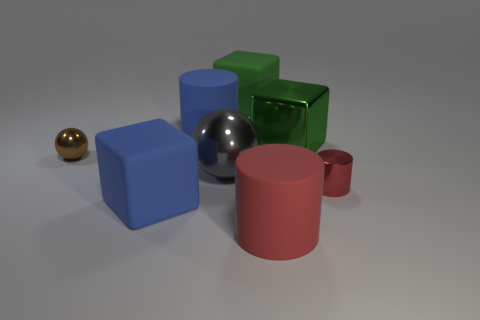How many things are either small metallic objects or small purple rubber cubes?
Your answer should be compact. 2. There is a metal object that is both on the right side of the brown shiny object and behind the big gray metallic object; how big is it?
Keep it short and to the point. Large. Are there fewer tiny brown metal things right of the large green shiny thing than large red cylinders?
Offer a terse response. Yes. The brown thing that is the same material as the large gray ball is what shape?
Provide a short and direct response. Sphere. Is the shape of the gray thing that is left of the red metal cylinder the same as the blue rubber object that is behind the big green shiny object?
Keep it short and to the point. No. Is the number of large matte cylinders behind the gray shiny thing less than the number of big green things to the left of the blue rubber cylinder?
Provide a succinct answer. No. What is the shape of the thing that is the same color as the tiny metallic cylinder?
Your answer should be compact. Cylinder. What number of green matte things are the same size as the red metallic object?
Your answer should be very brief. 0. Is the material of the large block that is on the left side of the big green rubber cube the same as the brown thing?
Offer a very short reply. No. Are there any tiny yellow shiny cylinders?
Your answer should be very brief. No. 